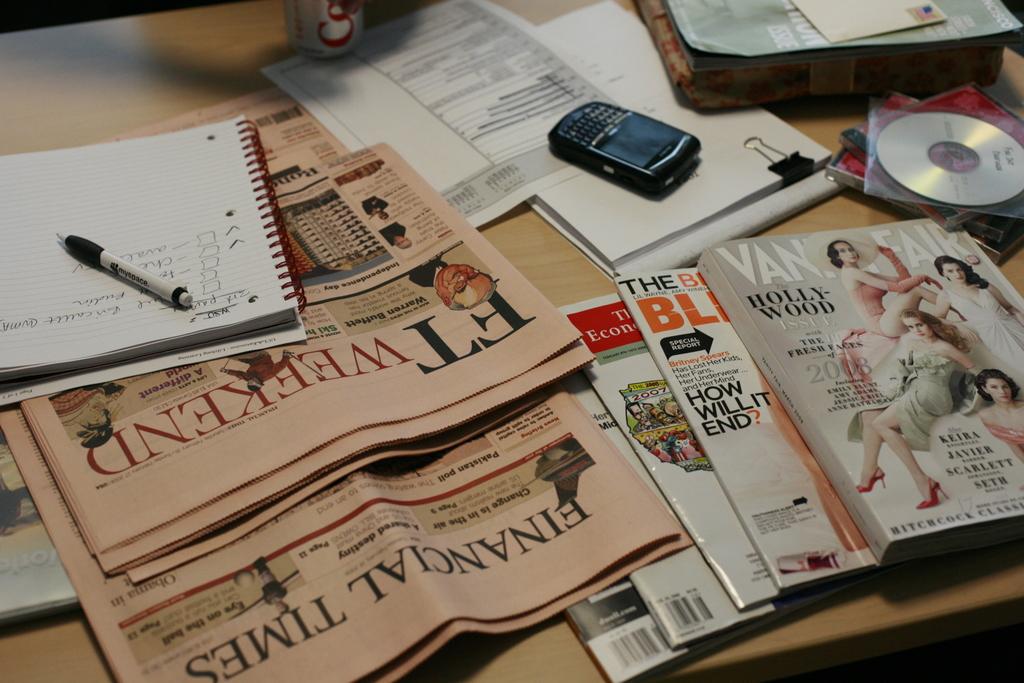What is the name of the newspaper?
Offer a very short reply. Financial times. What is the name of the magazine?
Offer a terse response. Vanity fair. 